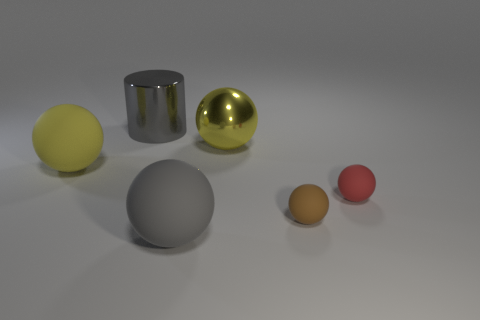There is a tiny matte thing that is on the right side of the small brown rubber thing in front of the red ball; what shape is it? The item you are referring to appears to be a small brown sphere, akin to a miniature, matte-finished ball. 